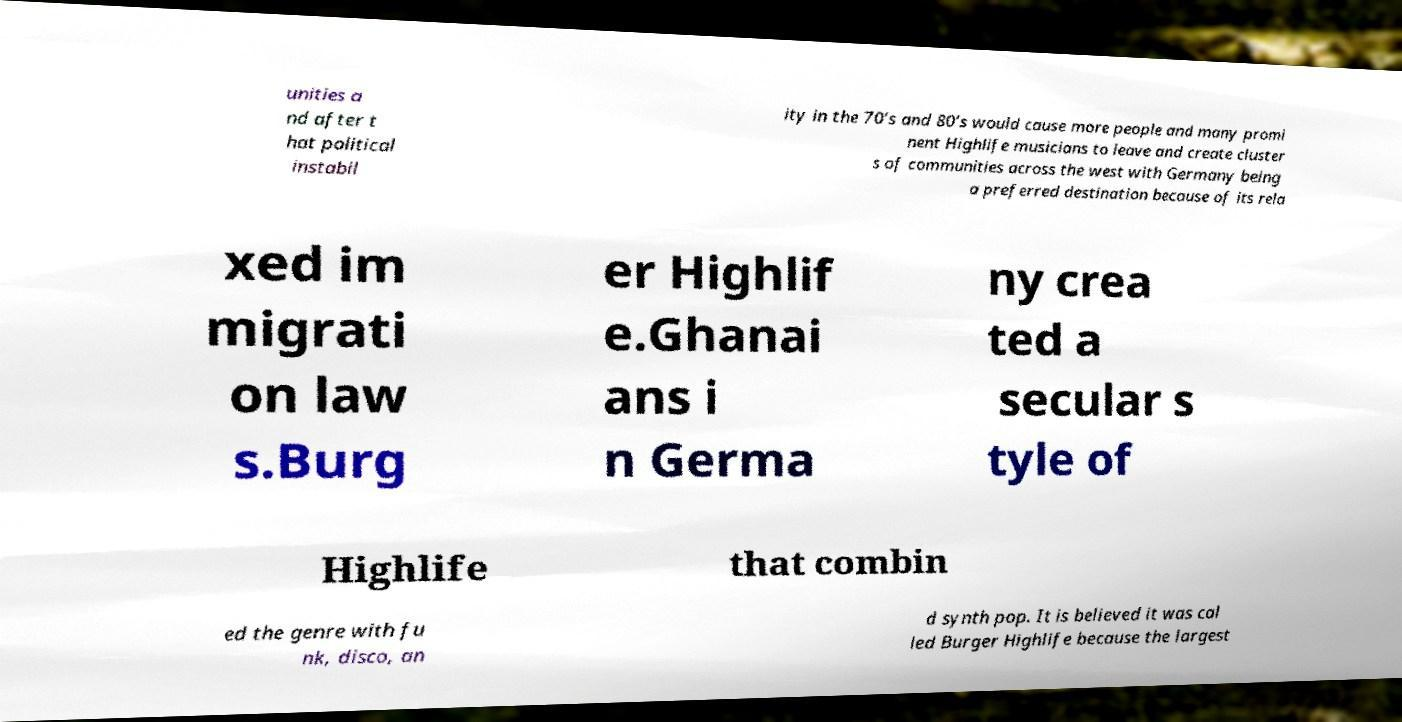Can you accurately transcribe the text from the provided image for me? unities a nd after t hat political instabil ity in the 70’s and 80’s would cause more people and many promi nent Highlife musicians to leave and create cluster s of communities across the west with Germany being a preferred destination because of its rela xed im migrati on law s.Burg er Highlif e.Ghanai ans i n Germa ny crea ted a secular s tyle of Highlife that combin ed the genre with fu nk, disco, an d synth pop. It is believed it was cal led Burger Highlife because the largest 